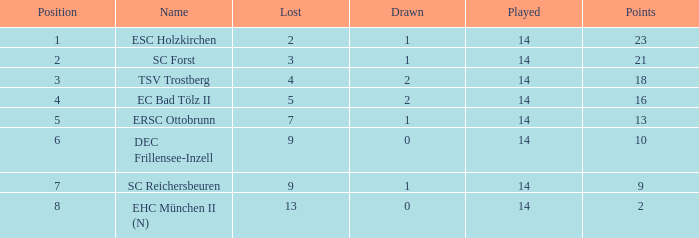How much Drawn has a Lost of 2, and Played smaller than 14? None. 